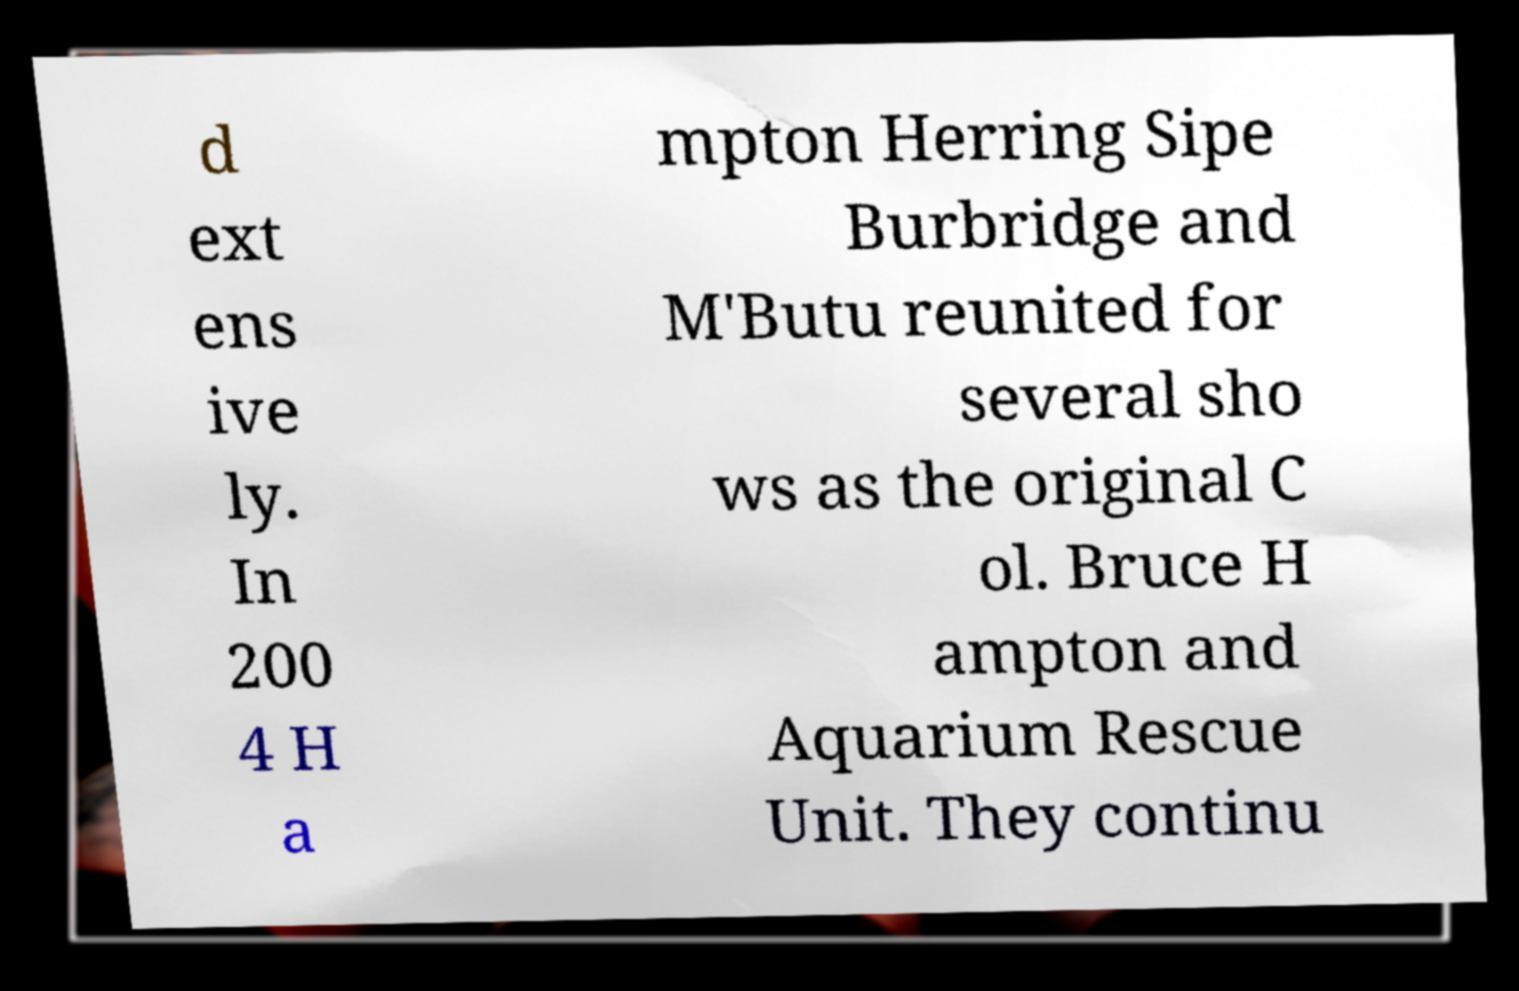Could you assist in decoding the text presented in this image and type it out clearly? d ext ens ive ly. In 200 4 H a mpton Herring Sipe Burbridge and M'Butu reunited for several sho ws as the original C ol. Bruce H ampton and Aquarium Rescue Unit. They continu 